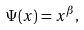Convert formula to latex. <formula><loc_0><loc_0><loc_500><loc_500>\ \Psi ( x ) = x ^ { \beta } ,</formula> 